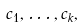Convert formula to latex. <formula><loc_0><loc_0><loc_500><loc_500>c _ { 1 } , \dots , c _ { k } ,</formula> 